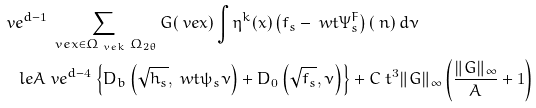Convert formula to latex. <formula><loc_0><loc_0><loc_500><loc_500>& \ v e ^ { d - 1 } \sum _ { \ v e x \in \Omega _ { \ v e k } \ \Omega _ { 2 \theta } } G ( \ v e x ) \int \eta ^ { k } ( x ) \left ( f _ { s } - \ w t { \Psi } _ { s } ^ { F } \right ) ( \ n ) \, d \nu \\ & \quad l e A \ v e ^ { d - 4 } \left \{ D _ { b } \left ( \sqrt { h _ { s } } , \ w t { \psi } _ { s } \nu \right ) + D _ { 0 } \left ( \sqrt { f _ { s } } , \nu \right ) \right \} + C \ t ^ { 3 } \| G \| _ { \infty } \left ( \frac { \| G \| _ { \infty } } { A } + 1 \right )</formula> 